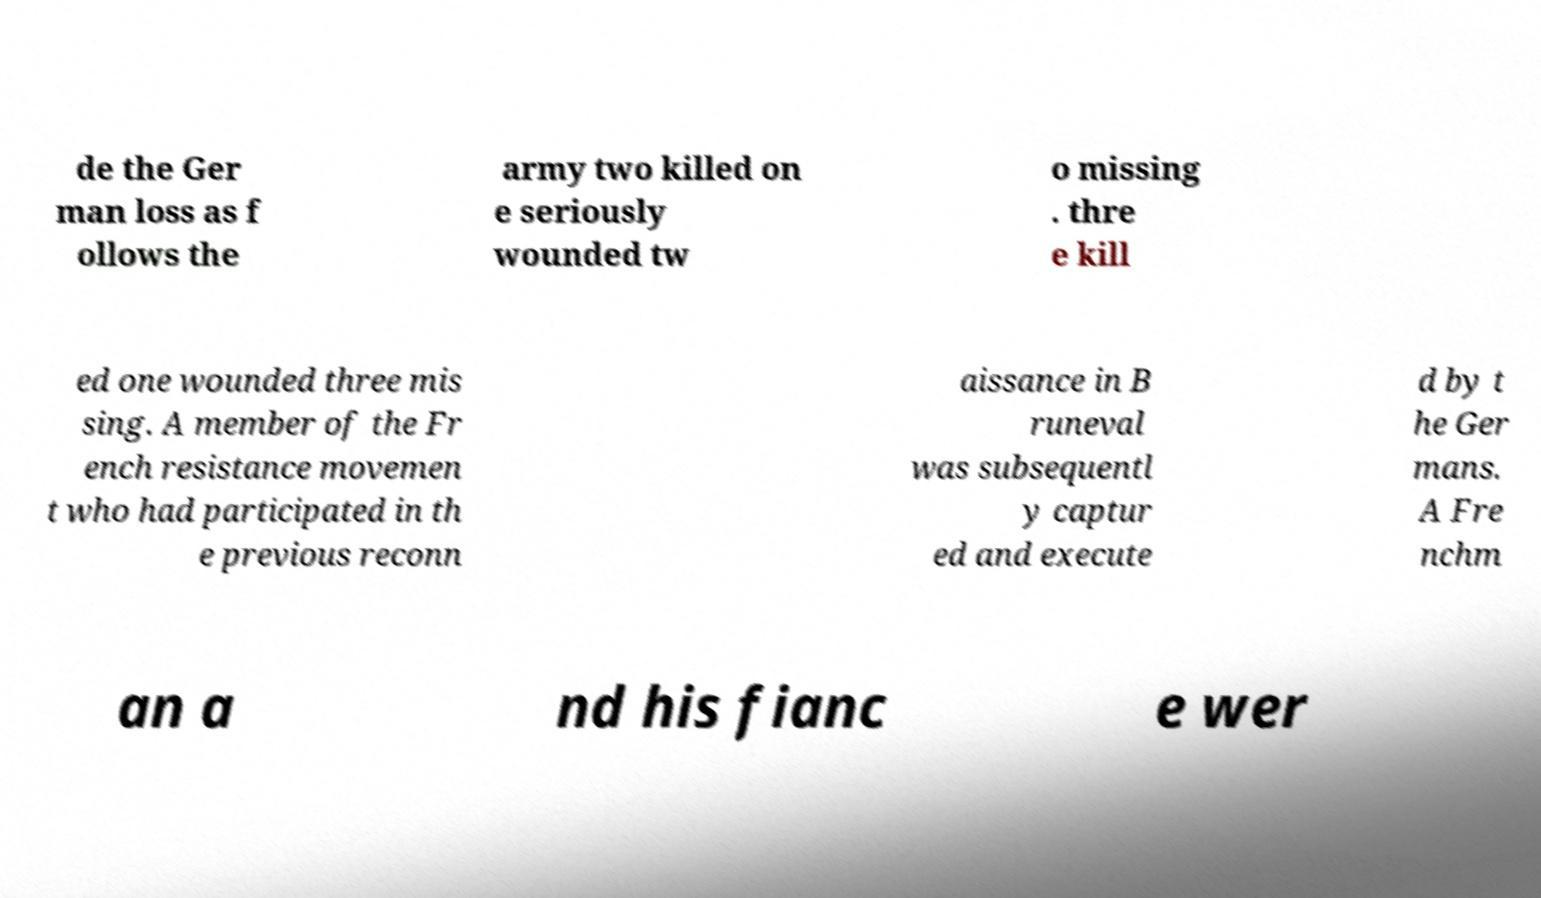Could you extract and type out the text from this image? de the Ger man loss as f ollows the army two killed on e seriously wounded tw o missing . thre e kill ed one wounded three mis sing. A member of the Fr ench resistance movemen t who had participated in th e previous reconn aissance in B runeval was subsequentl y captur ed and execute d by t he Ger mans. A Fre nchm an a nd his fianc e wer 